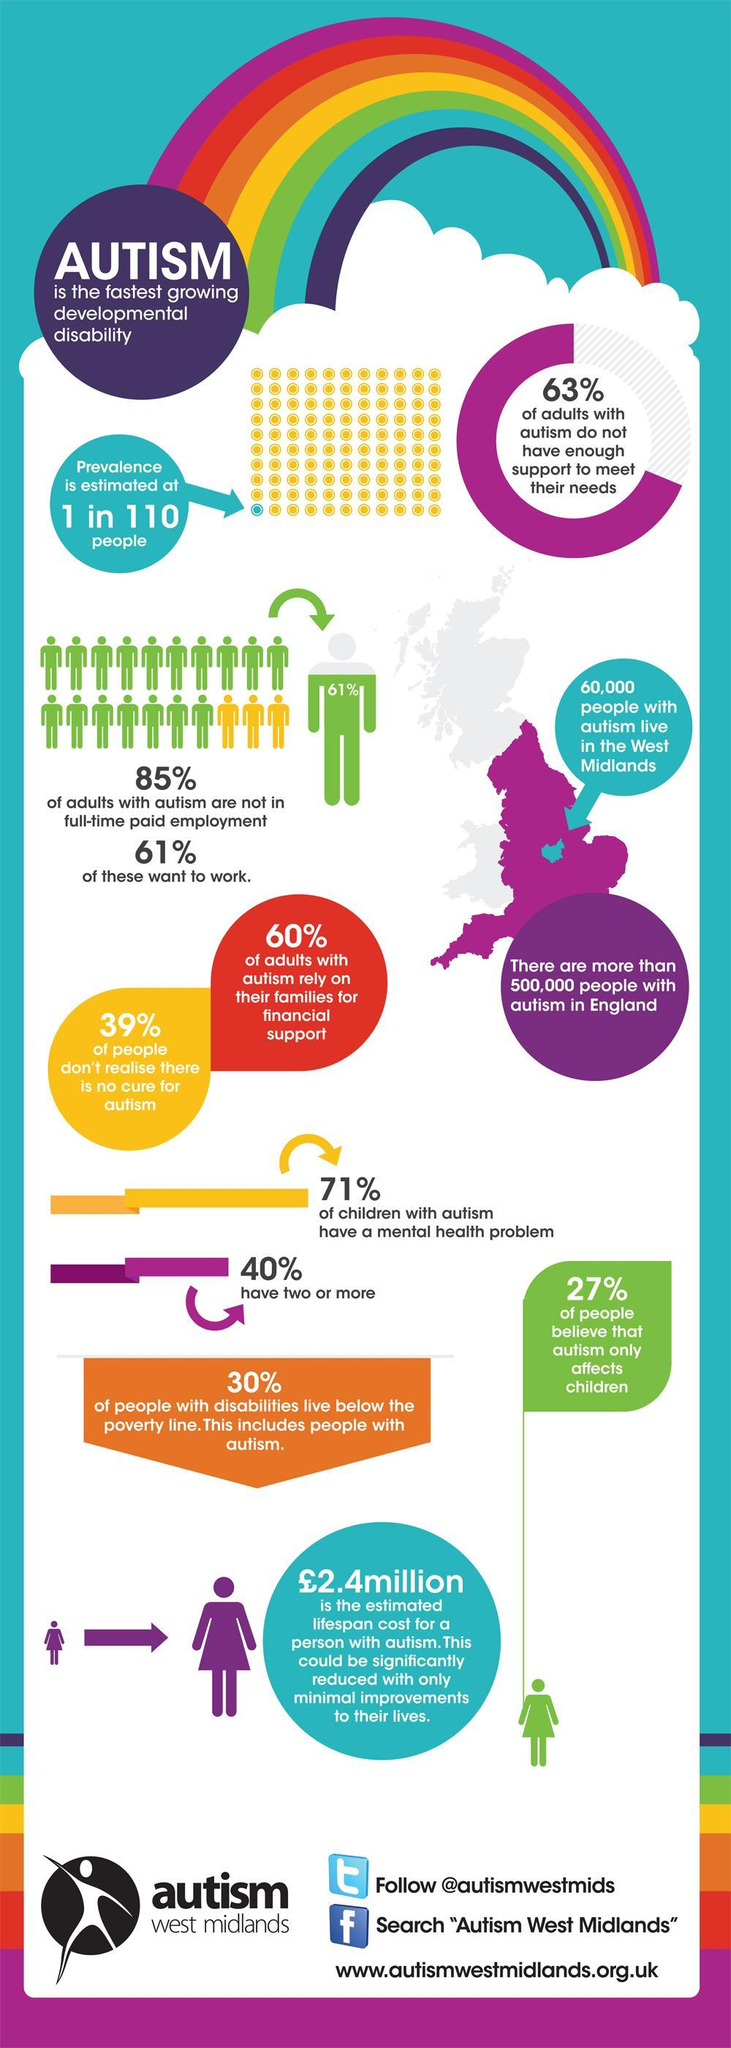What percentage of adults with autism have enough support to meet their needs in west midlands?
Answer the question with a short phrase. 37% What percentage of people realise that there is no cure for autism in England? 61% What percentage of people believe that autism only affects children in England? 27% What percentage of adults with autism do not rely on their families for financial support in west midlands? 40% What percentage of adults with autism are not in full-time payment in England? 85% 